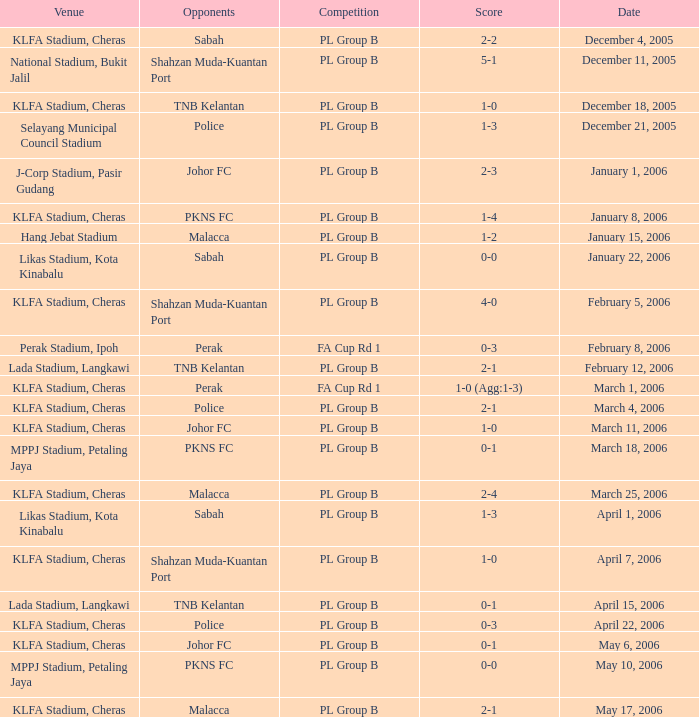Which Competition has Opponents of pkns fc, and a Score of 0-0? PL Group B. 